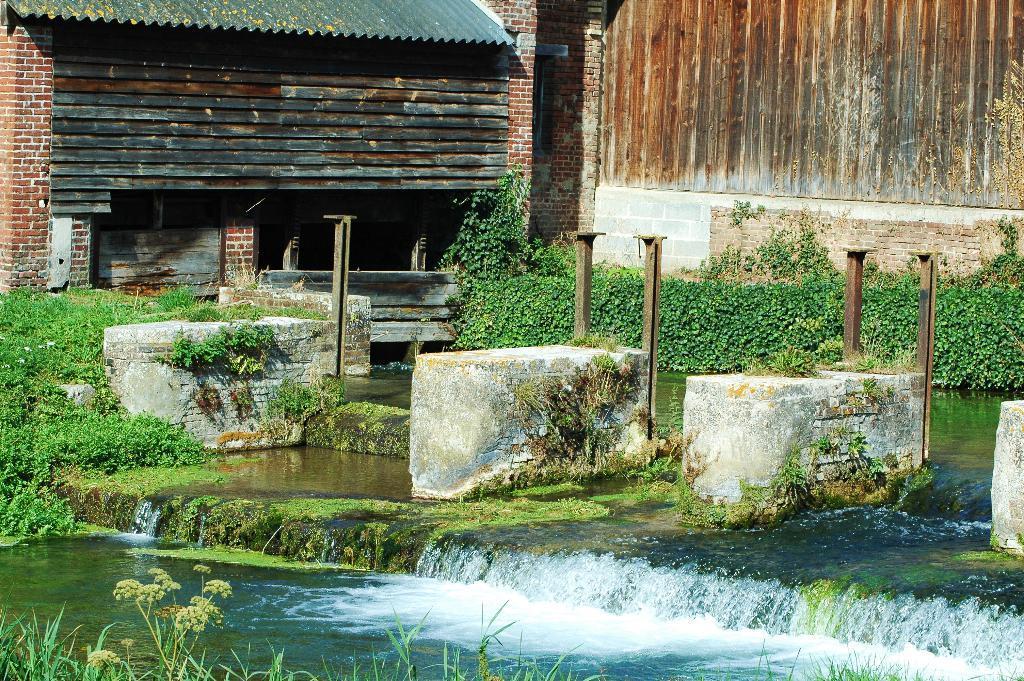Please provide a concise description of this image. In the bottom of the image there is water. There are plants. In the background of the image there is wall. 